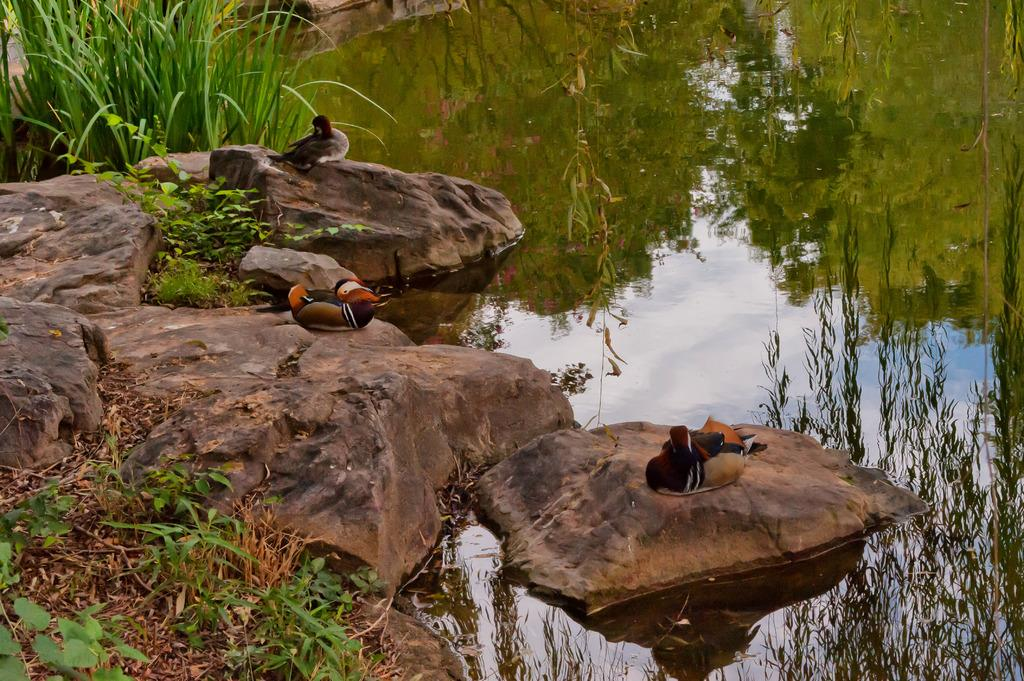What type of natural elements can be seen in the image? There are rocks, plants, grass, and water visible in the image. How many birds are present on the rocks in the image? There are 3 birds on the rocks in the image. What is the reflection of in the water? The reflection of trees and the sky is visible in the water. What flavor of oranges can be seen in the image? There are no oranges present in the image, so it is not possible to determine their flavor. 